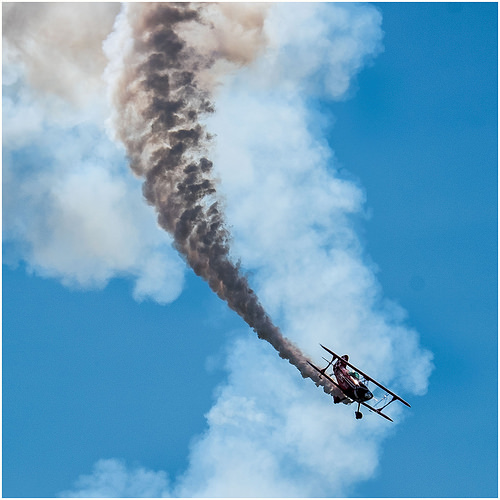<image>
Is the smoke on the sky? No. The smoke is not positioned on the sky. They may be near each other, but the smoke is not supported by or resting on top of the sky. 